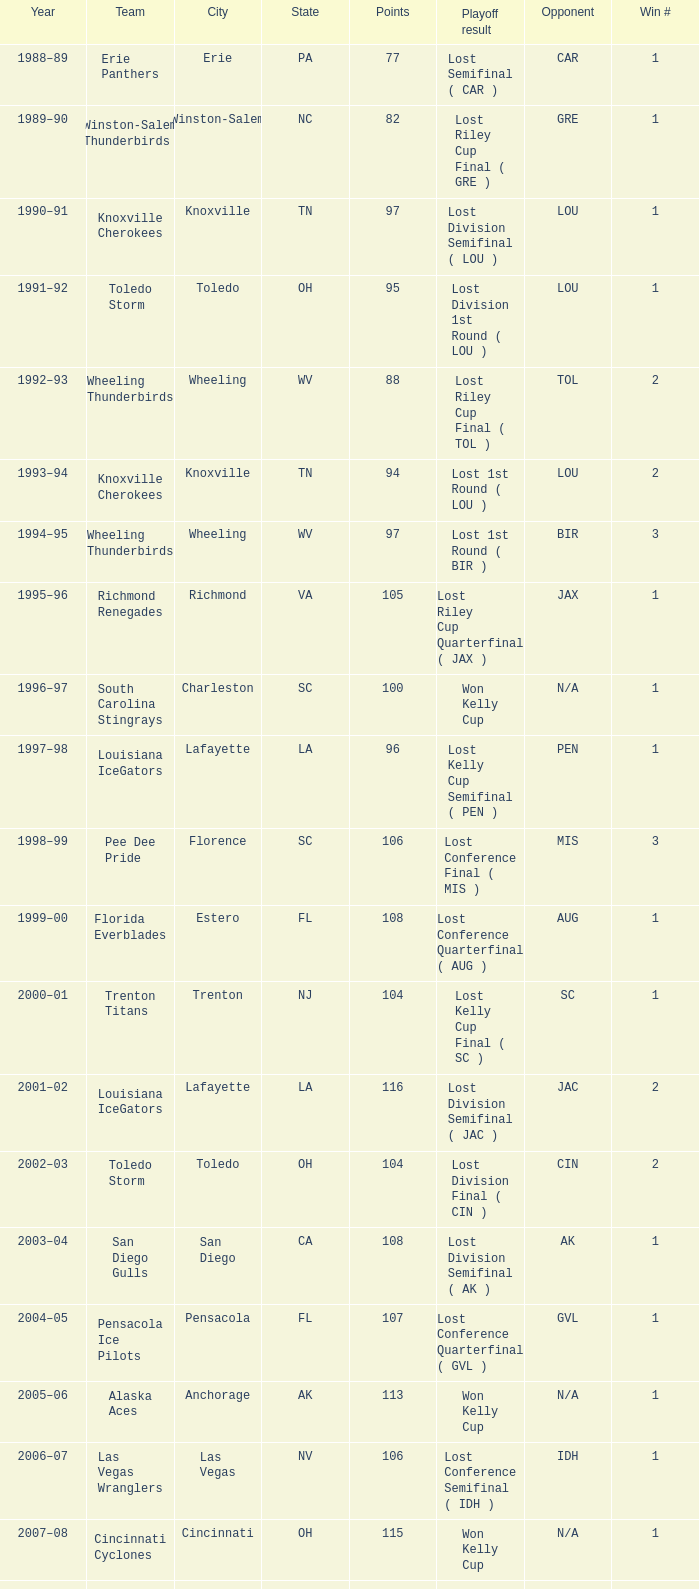What is Playoff Result, when Winner is "Alaska Aces", when Win # is greater than 1, when Points is less than 106, and when Year is "2011-12"? Lost Conference Final ( LV ). 